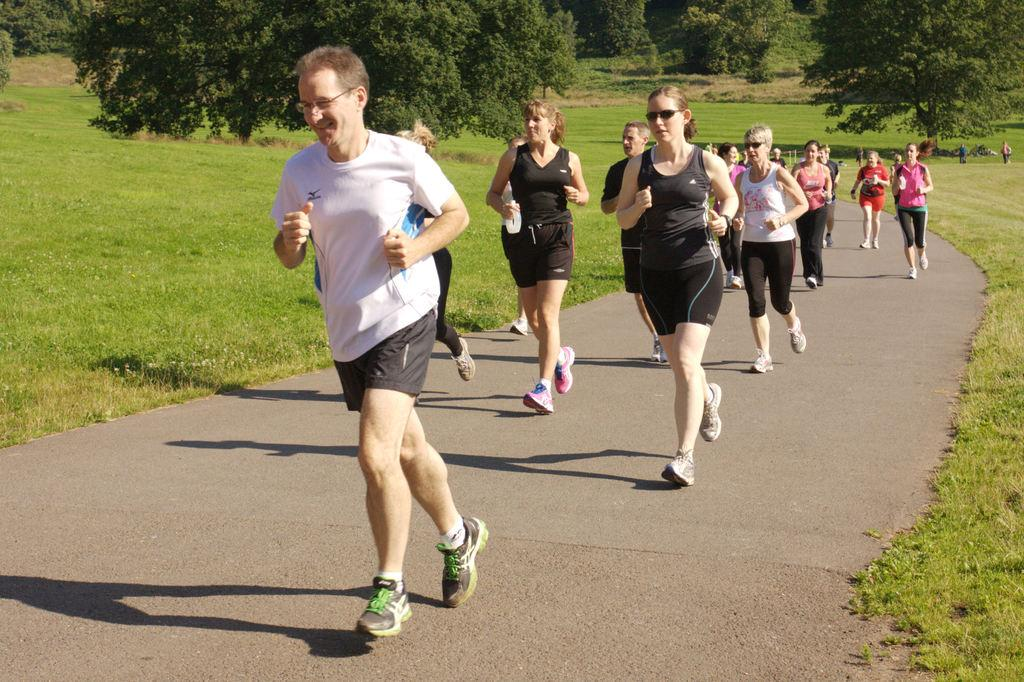What are the people in the image doing? The people in the image are running. Where are the people running? The people are running on a road. What can be seen in the background of the image? There are trees in the background of the image. What type of surface are the people running on? The people are running on grass, which is visible in the image. What type of secretary can be seen working in the image? There is no secretary present in the image; it features people running on a road with trees in the background. 